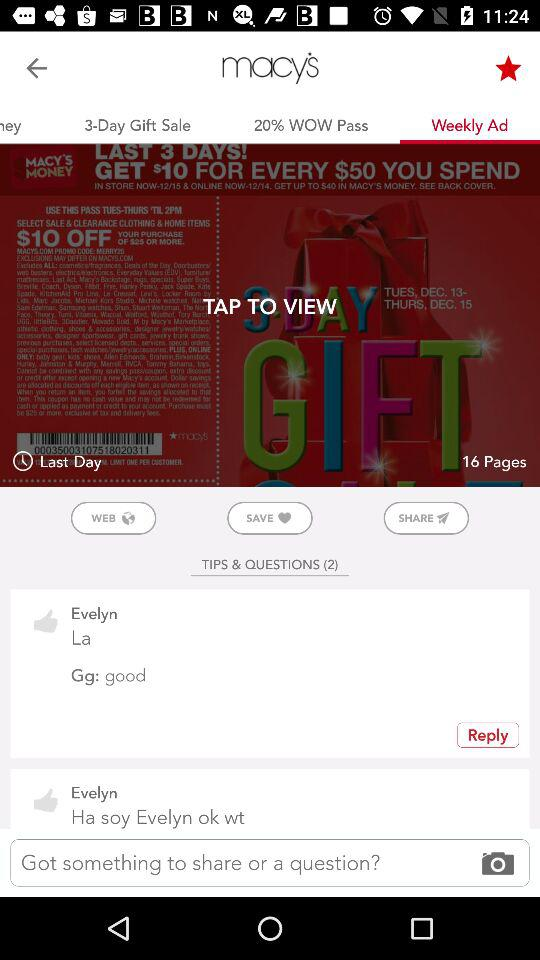How many pages are given? There are 16 pages. 